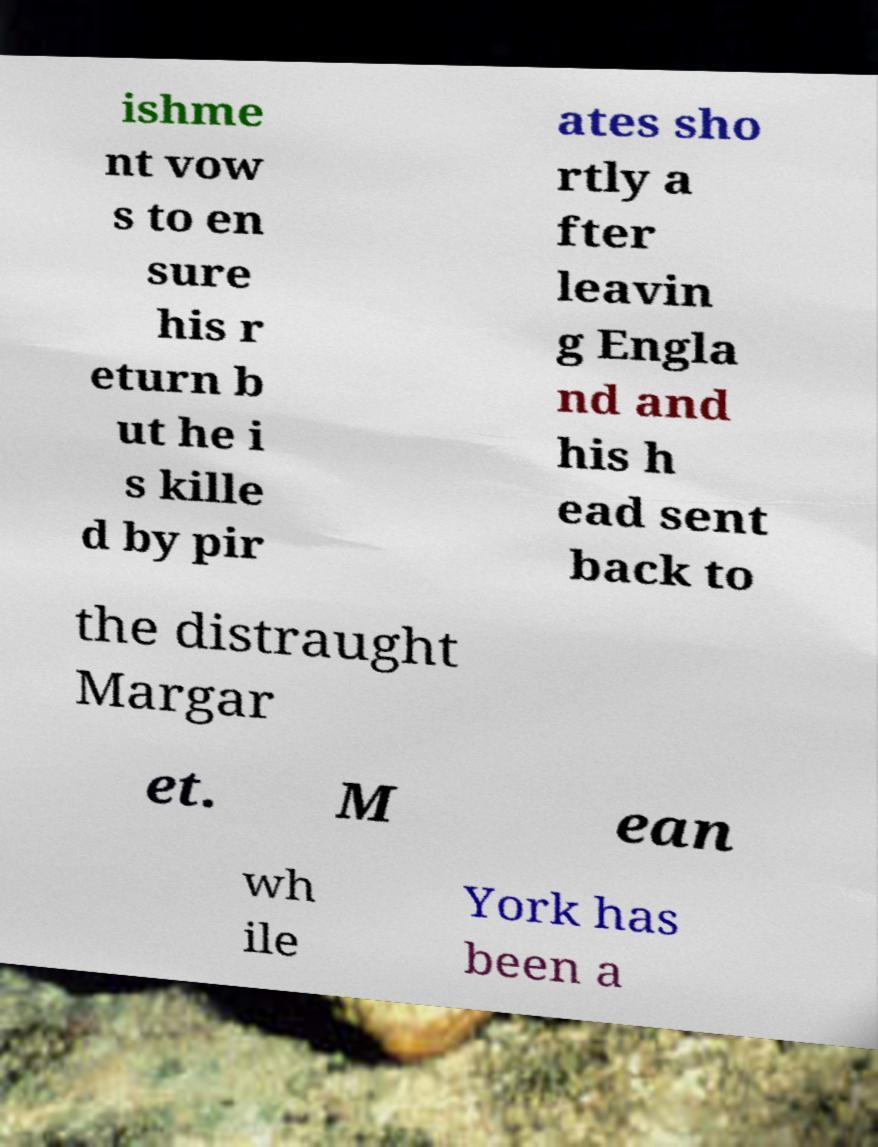Could you extract and type out the text from this image? ishme nt vow s to en sure his r eturn b ut he i s kille d by pir ates sho rtly a fter leavin g Engla nd and his h ead sent back to the distraught Margar et. M ean wh ile York has been a 